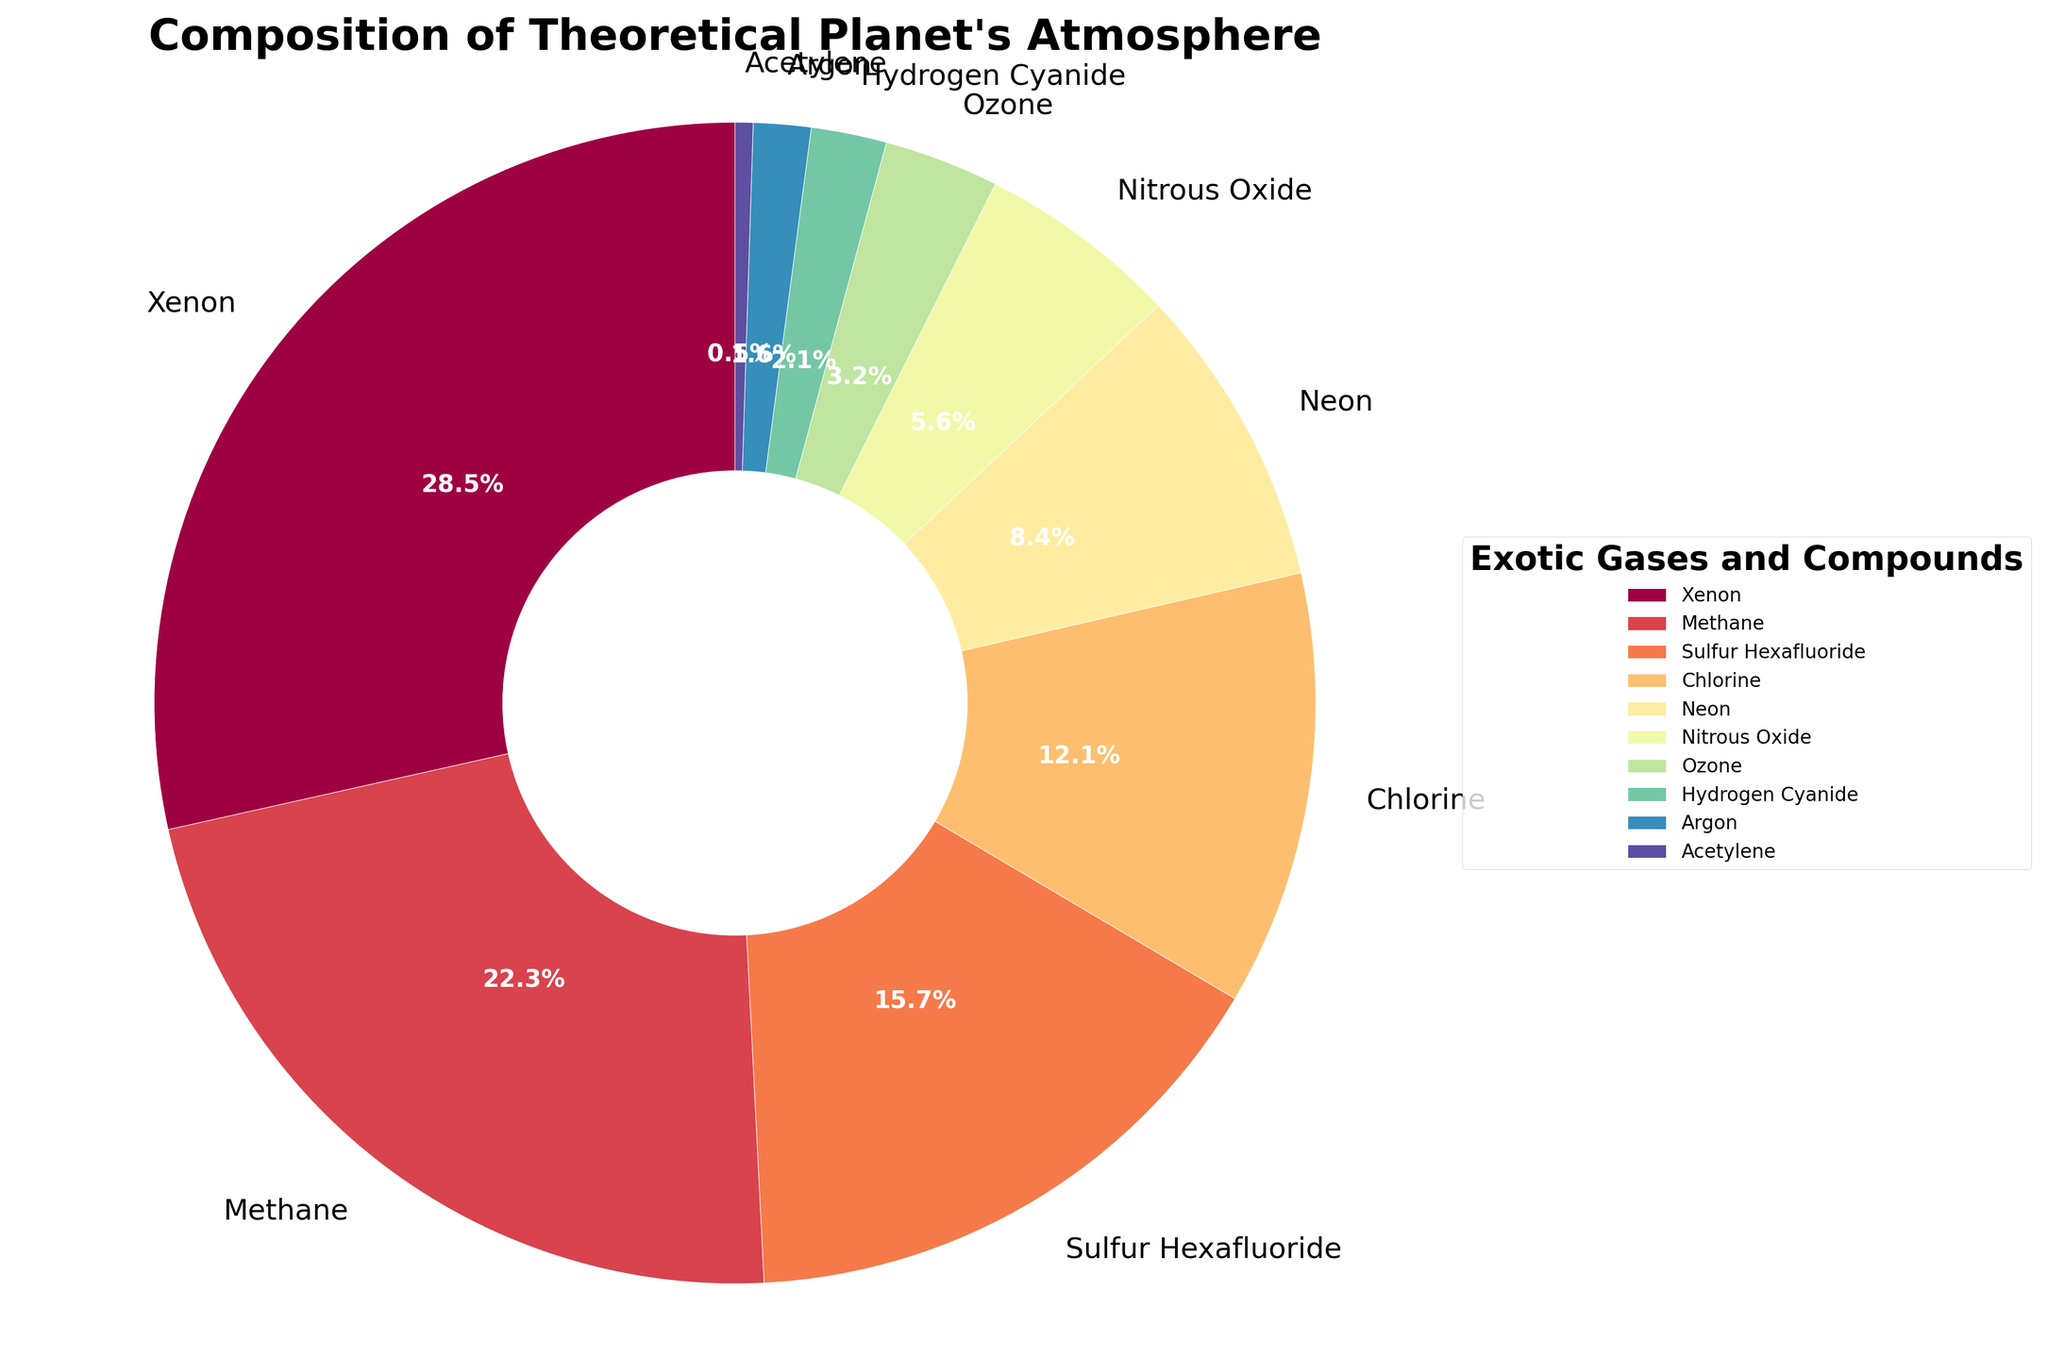What is the combined percentage of Xenon and Methane? To find the combined percentage of Xenon and Methane, simply add their individual percentages: 28.5% (Xenon) + 22.3% (Methane) = 50.8%
Answer: 50.8% Which gas has a higher percentage, Sulfur Hexafluoride or Chlorine? By examining the figure, Sulfur Hexafluoride has a percentage of 15.7%, and Chlorine has a percentage of 12.1%. Since 15.7% > 12.1%, Sulfur Hexafluoride has a higher percentage than Chlorine.
Answer: Sulfur Hexafluoride What is the smallest percentage of any gas, and which gas does it correspond to? The figure shows that Acetylene has the smallest percentage at 0.5%.
Answer: 0.5%, Acetylene How much more percentage does Neon contribute compared to Nitrous Oxide? Calculate the difference between the two percentages: 8.4% (Neon) - 5.6% (Nitrous Oxide) = 2.8%.
Answer: 2.8% What is the average percentage of Neon, Ozone, and Hydrogen Cyanide? First, sum up the percentages: 8.4% (Neon) + 3.2% (Ozone) + 2.1% (Hydrogen Cyanide) = 13.7%. Then divide by the number of gases (3): 13.7% / 3 ≈ 4.57%.
Answer: 4.57% Which gas occupies approximately one-fourth of the total percentage? By looking at the figure, Xenon is the gas that occupies 28.5%, which is approximately one-fourth of the total (25%).
Answer: Xenon If we combine Chlorine and Argon, do they make up more than Methane alone? Calculate the combined percentage of Chlorine and Argon: 12.1% (Chlorine) + 1.6% (Argon) = 13.7%. Methane alone is 22.3%, so Chlorine and Argon together contribute less than Methane alone.
Answer: No What percentage of the atmosphere do the bottom three gases (Nitrous Oxide, Ozone, Hydrogen Cyanide) together account for? Sum the percentages of the bottom three gases: 5.6% (Nitrous Oxide) + 3.2% (Ozone) + 2.1% (Hydrogen Cyanide) = 10.9%.
Answer: 10.9% Which gas is represented by the color nearest to red on the pie chart? Examining the color scheme, the gas represented by the color nearest to red is Xenon.
Answer: Xenon Is Sulfur Hexafluoride more than or less than twice the percentage of Acetylene? Sulfur Hexafluoride is 15.7%, and Acetylene is 0.5%. Twice the percentage of Acetylene is 0.5% * 2 = 1.0%. Since 15.7% > 1.0%, Sulfur Hexafluoride is more than twice the percentage of Acetylene.
Answer: More 